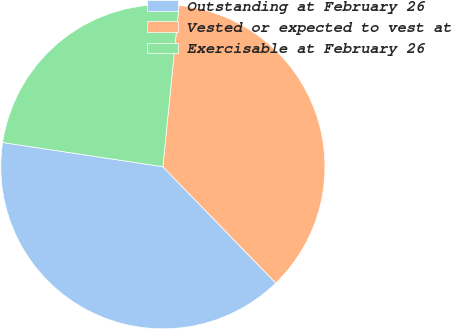Convert chart to OTSL. <chart><loc_0><loc_0><loc_500><loc_500><pie_chart><fcel>Outstanding at February 26<fcel>Vested or expected to vest at<fcel>Exercisable at February 26<nl><fcel>39.65%<fcel>36.15%<fcel>24.2%<nl></chart> 